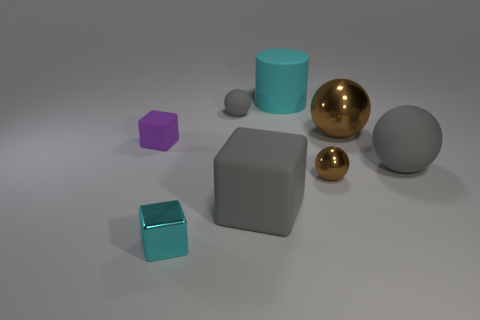Are there any other things that are the same size as the purple matte thing?
Give a very brief answer. Yes. There is a large ball that is the same material as the large cylinder; what is its color?
Your response must be concise. Gray. How many cylinders are large gray matte things or big purple shiny things?
Ensure brevity in your answer.  0. What number of things are either gray rubber spheres or rubber things to the right of the large cyan rubber object?
Ensure brevity in your answer.  2. Are there any tiny cyan matte cylinders?
Your answer should be very brief. No. What number of big cubes have the same color as the small metallic sphere?
Give a very brief answer. 0. There is a tiny object that is the same color as the cylinder; what is its material?
Keep it short and to the point. Metal. There is a gray rubber thing behind the brown shiny ball behind the small brown ball; what size is it?
Give a very brief answer. Small. Are there any big objects made of the same material as the cyan block?
Your answer should be very brief. Yes. There is a purple thing that is the same size as the cyan shiny block; what is its material?
Provide a succinct answer. Rubber. 